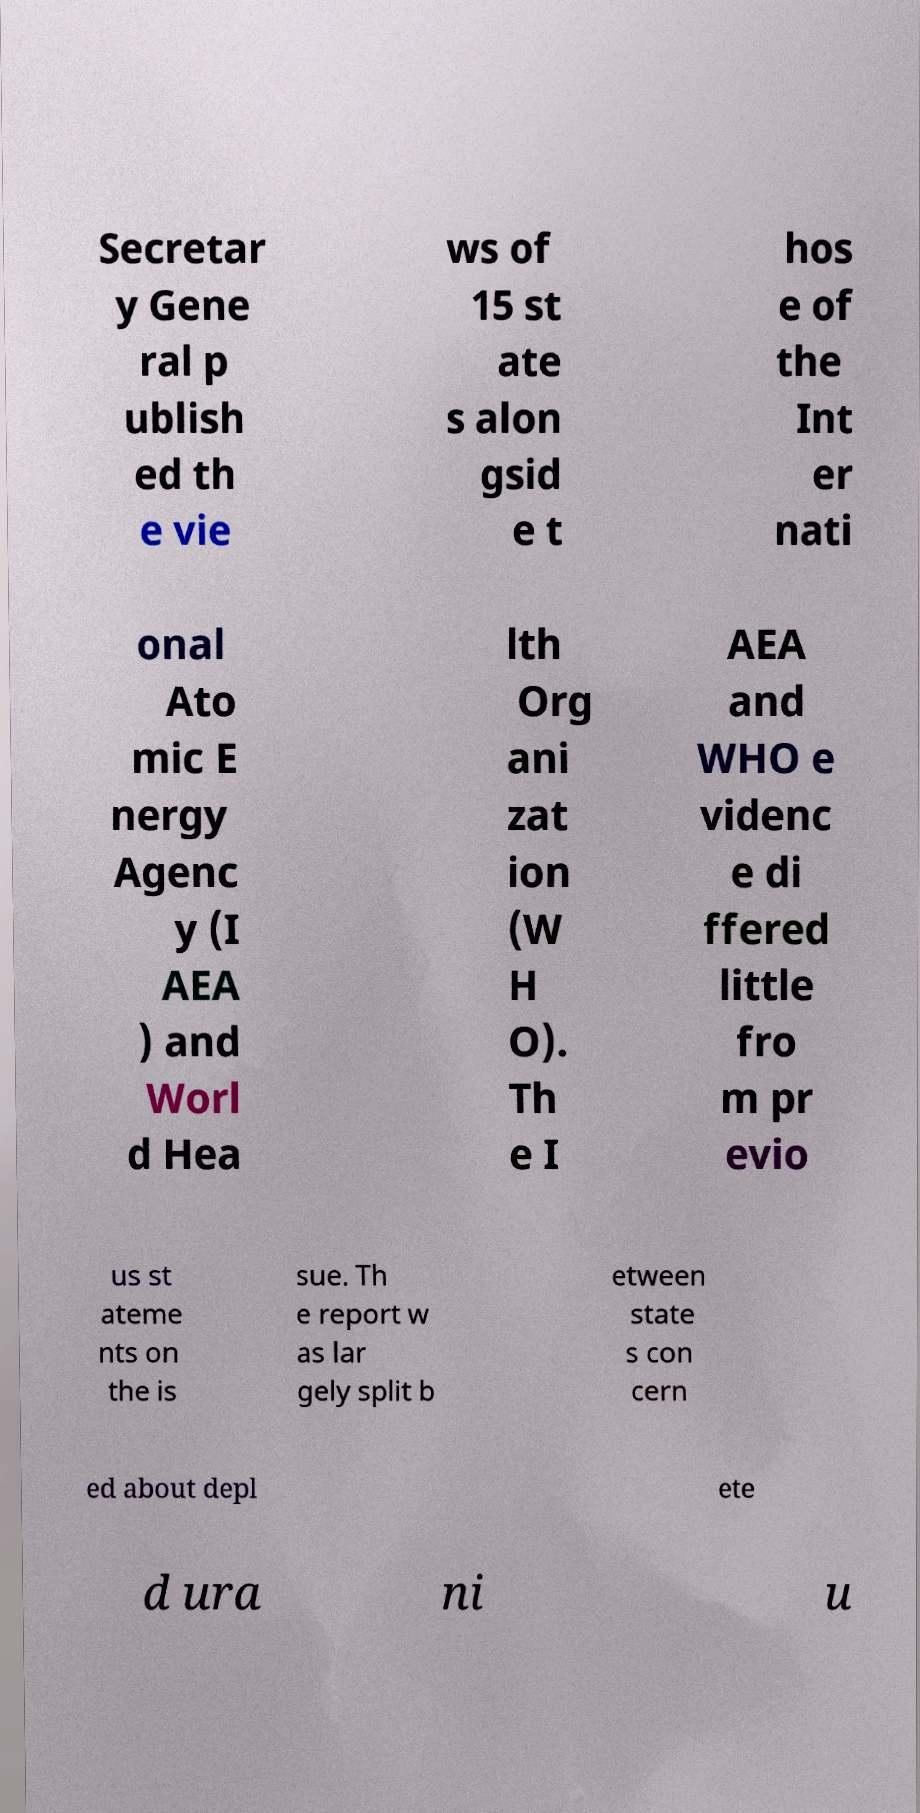What messages or text are displayed in this image? I need them in a readable, typed format. Secretar y Gene ral p ublish ed th e vie ws of 15 st ate s alon gsid e t hos e of the Int er nati onal Ato mic E nergy Agenc y (I AEA ) and Worl d Hea lth Org ani zat ion (W H O). Th e I AEA and WHO e videnc e di ffered little fro m pr evio us st ateme nts on the is sue. Th e report w as lar gely split b etween state s con cern ed about depl ete d ura ni u 